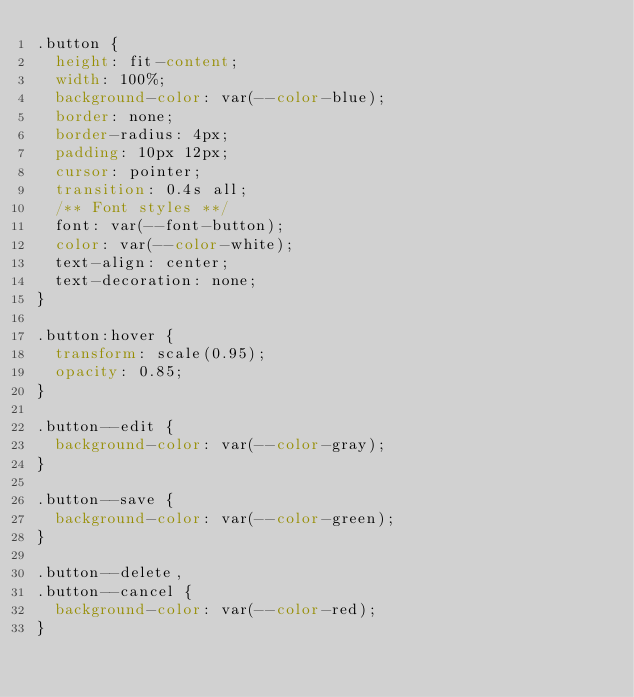Convert code to text. <code><loc_0><loc_0><loc_500><loc_500><_CSS_>.button {
  height: fit-content;
  width: 100%;
  background-color: var(--color-blue);
  border: none;
  border-radius: 4px;
  padding: 10px 12px;
  cursor: pointer;
  transition: 0.4s all;
  /** Font styles **/
  font: var(--font-button);
  color: var(--color-white);
  text-align: center;
  text-decoration: none;
}

.button:hover {
  transform: scale(0.95);
  opacity: 0.85;
}

.button--edit {
  background-color: var(--color-gray);
}

.button--save {
  background-color: var(--color-green);
}

.button--delete,
.button--cancel {
  background-color: var(--color-red);
}
</code> 